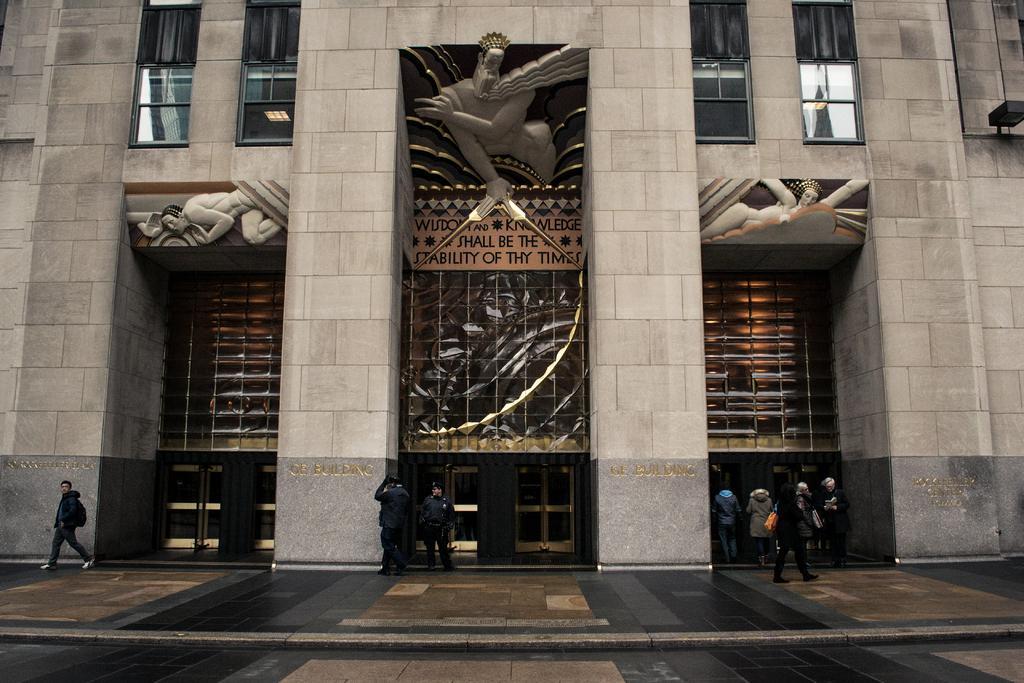In one or two sentences, can you explain what this image depicts? In this image we can see a building, there are the persons standing on the ground, here are the pillars, here is the glass window. 